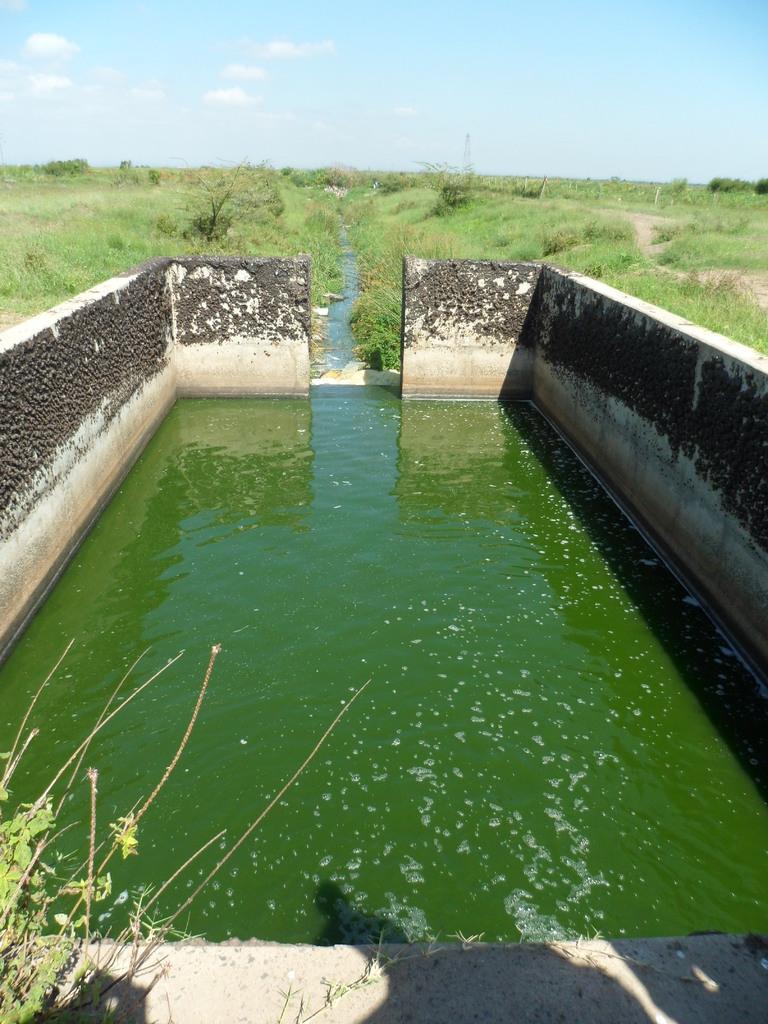How would you summarize this image in a sentence or two? This image consists of a water body. At the bottom, there is water. On the left and right, there are walls. In the background, there are small plants and grass on the ground. At the top, there are clouds in the sky. 